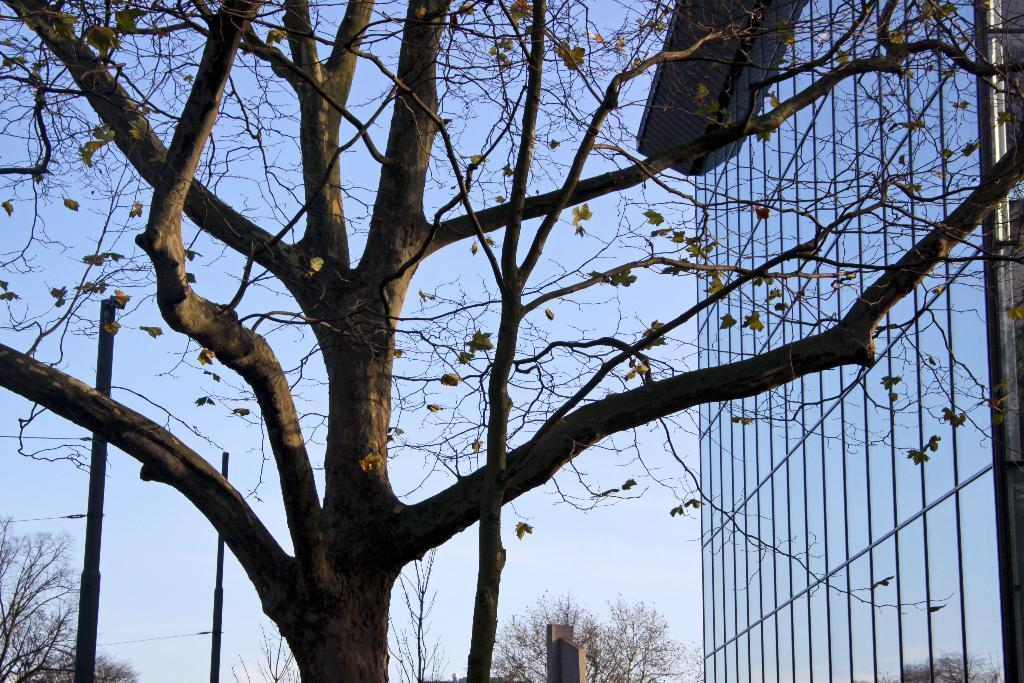What type of vegetation is present in the image? There are trees with branches in the image. What type of structure can be seen on the right side of the image? There is a glass building on the right side of the image. What is visible in the sky in the image? Clouds are visible in the sky. What type of house is visible in the image? There is no house present in the image; it features trees and a glass building. What is the weather like in the image? The provided facts do not mention the weather, so we cannot determine the weather from the image. 